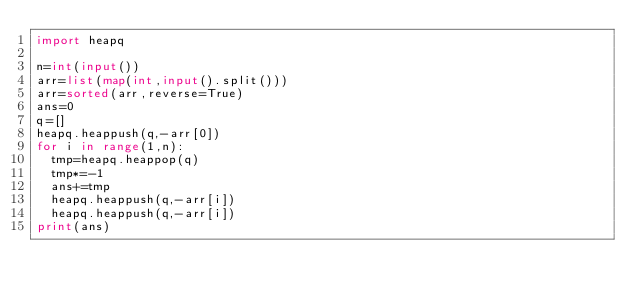Convert code to text. <code><loc_0><loc_0><loc_500><loc_500><_Python_>import heapq

n=int(input())
arr=list(map(int,input().split()))
arr=sorted(arr,reverse=True)
ans=0
q=[]
heapq.heappush(q,-arr[0])
for i in range(1,n):
  tmp=heapq.heappop(q)
  tmp*=-1
  ans+=tmp
  heapq.heappush(q,-arr[i])
  heapq.heappush(q,-arr[i])
print(ans)</code> 